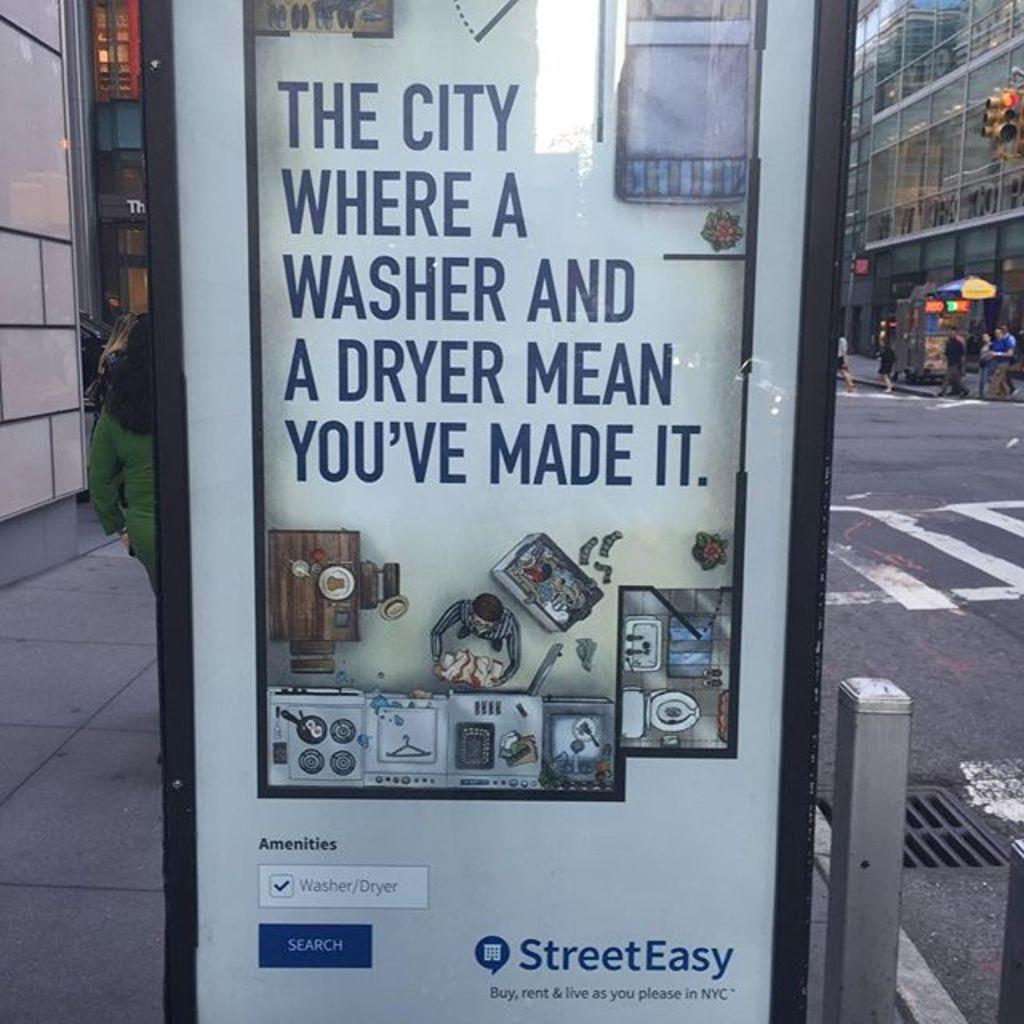<image>
Present a compact description of the photo's key features. A banner advertisement for StreetEasy app that aids buying or renting housing amenities in NYC. 